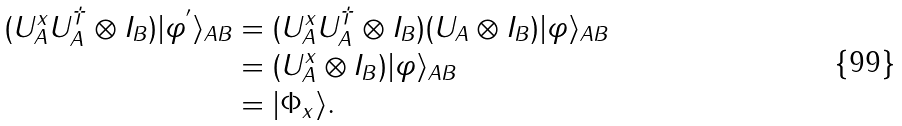Convert formula to latex. <formula><loc_0><loc_0><loc_500><loc_500>( U _ { A } ^ { x } U _ { A } ^ { \dagger } \otimes I _ { B } ) | \varphi ^ { ^ { \prime } } \rangle _ { A B } & = ( U _ { A } ^ { x } U _ { A } ^ { \dagger } \otimes I _ { B } ) ( U _ { A } \otimes I _ { B } ) | \varphi \rangle _ { A B } \\ & = ( U _ { A } ^ { x } \otimes I _ { B } ) | \varphi \rangle _ { A B } \\ & = | \Phi _ { x } \rangle .</formula> 